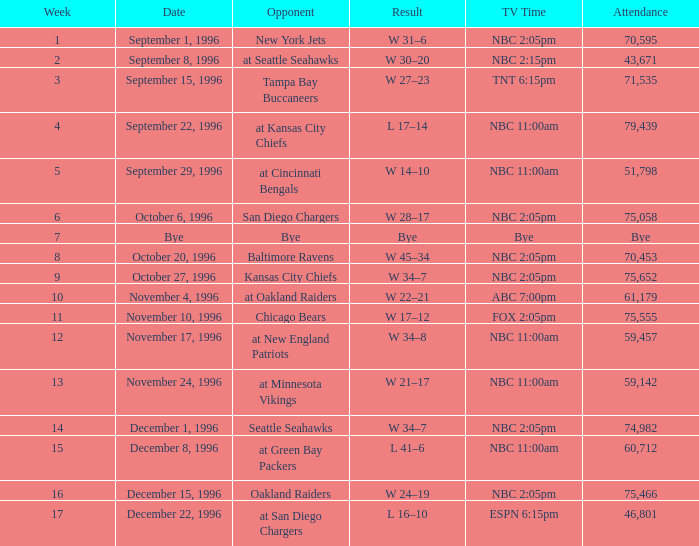WHAT IS THE WEEK WITH AN ATTENDANCE OF 75,555? 11.0. 